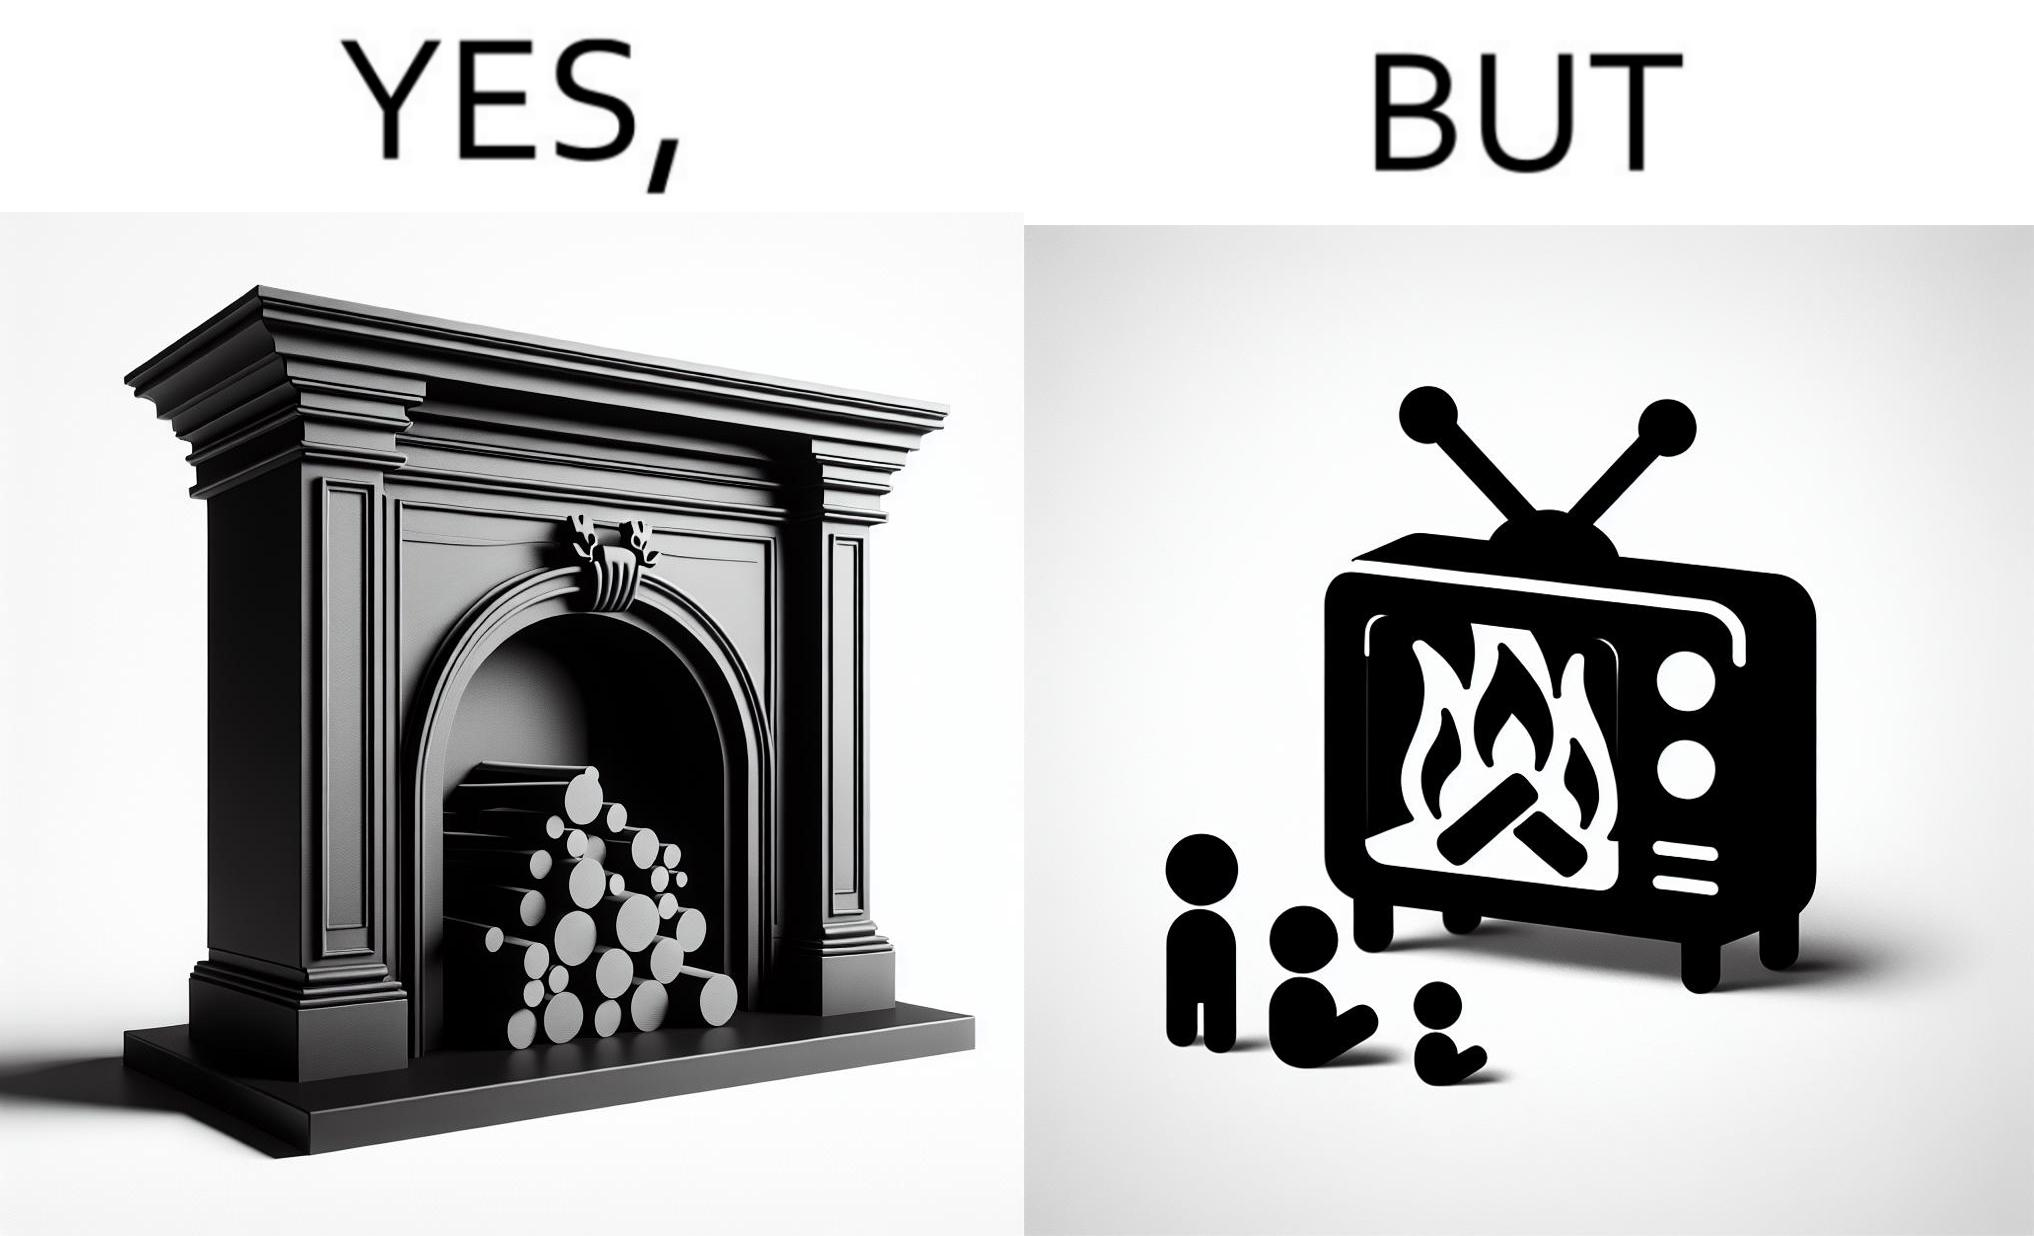Explain why this image is satirical. The images are funny since they show how even though real fireplaces exist, people choose to be lazy and watch fireplaces on television because they dont want the inconveniences of cleaning up, etc. afterwards 